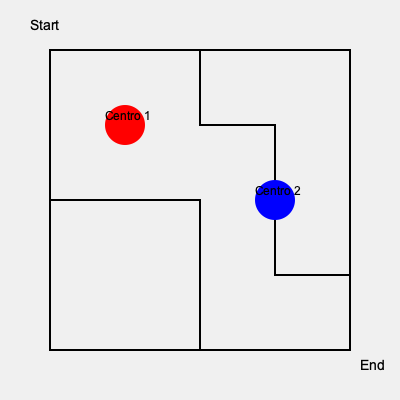In our effort to improve community access, we need to find the shortest path from the start point to the end point while passing through both community centers (red and blue circles). What is the minimum distance required to complete this route? To find the shortest path, we need to follow these steps:

1. Observe that the maze is composed of a grid where each small square is 75x75 units.

2. Calculate the distance from Start to Centro 1 (red circle):
   - 1 square right and 1 square down
   - Distance = $75 + 75 = 150$ units

3. Calculate the distance from Centro 1 to Centro 2 (blue circle):
   - 2 squares right and 1 square down
   - Distance = $75 * 2 + 75 = 225$ units

4. Calculate the distance from Centro 2 to End:
   - 1 square right and 1 square down
   - Distance = $75 + 75 = 150$ units

5. Sum up all the distances:
   $150 + 225 + 150 = 525$ units

Therefore, the minimum distance required to complete the route passing through both community centers is 525 units.
Answer: 525 units 